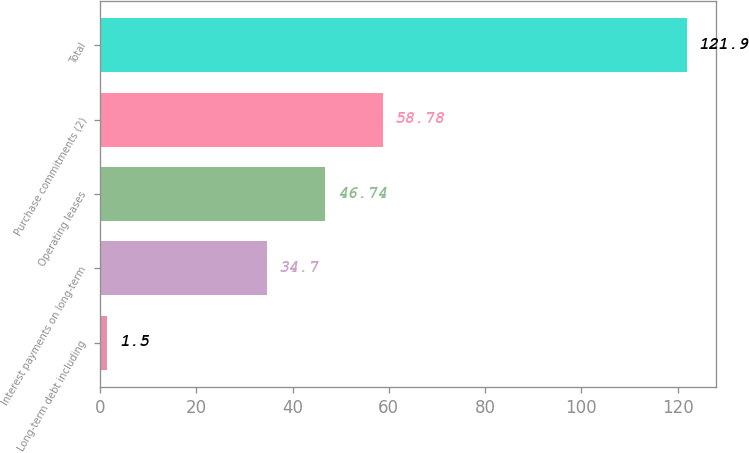Convert chart. <chart><loc_0><loc_0><loc_500><loc_500><bar_chart><fcel>Long-term debt including<fcel>Interest payments on long-term<fcel>Operating leases<fcel>Purchase commitments (2)<fcel>Total<nl><fcel>1.5<fcel>34.7<fcel>46.74<fcel>58.78<fcel>121.9<nl></chart> 